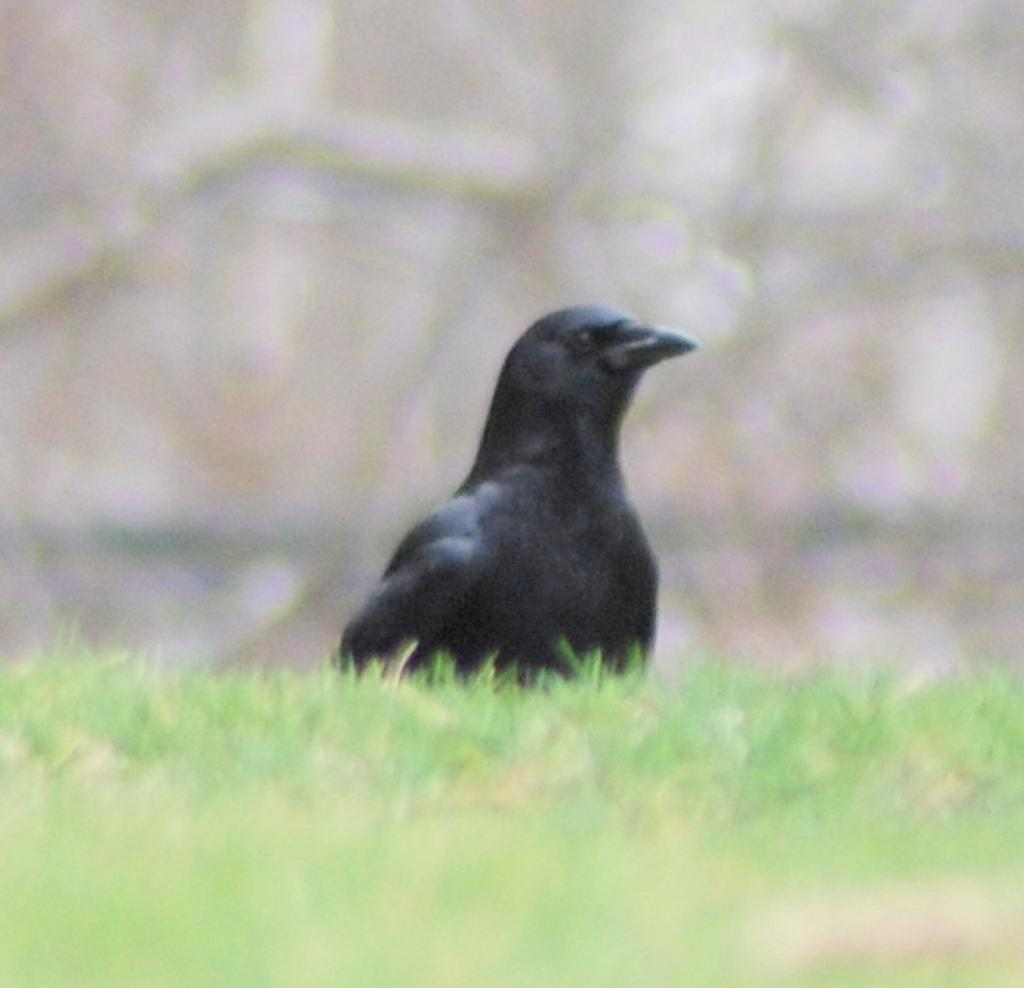What type of bird is in the image? There is a crow in the image. Where is the crow located in the image? The crow is in the middle of the image. What type of vegetation is at the bottom of the image? There is green grass at the bottom of the image. What type of glue is the crow using to stick the notebook in the image? There is no glue or notebook present in the image; it only features a crow and green grass. 